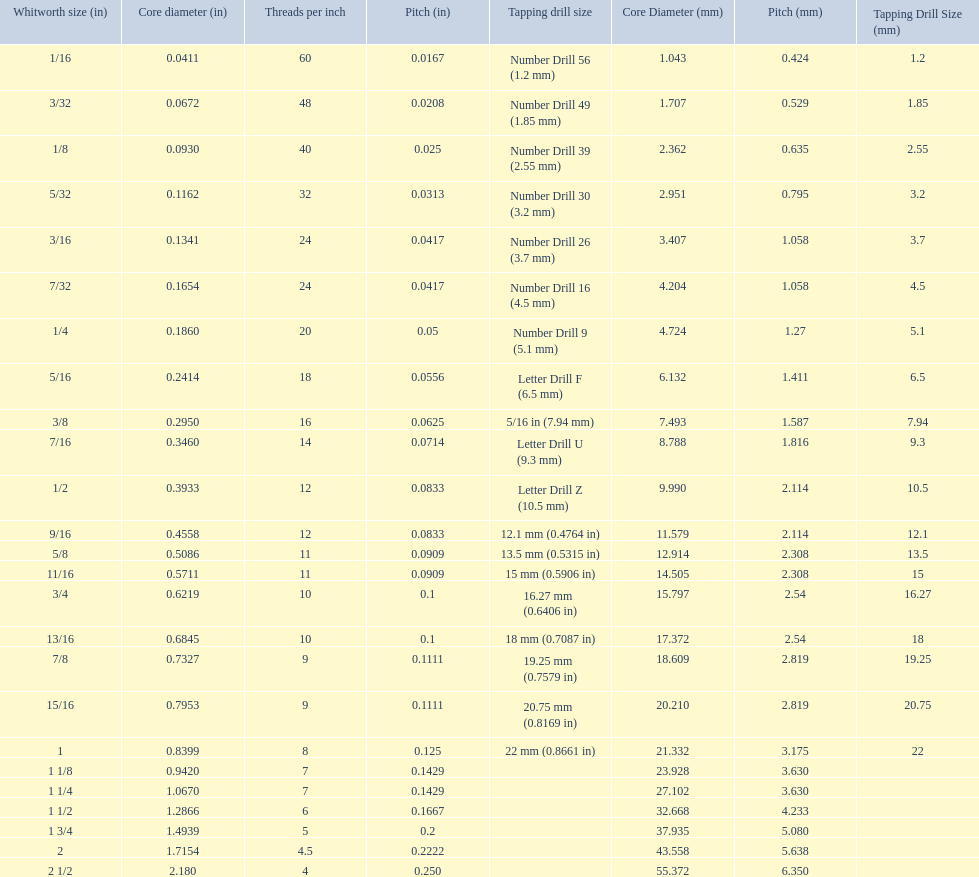What is the core diameter for the number drill 26? 0.1341. What is the whitworth size (in) for this core diameter? 3/16. 